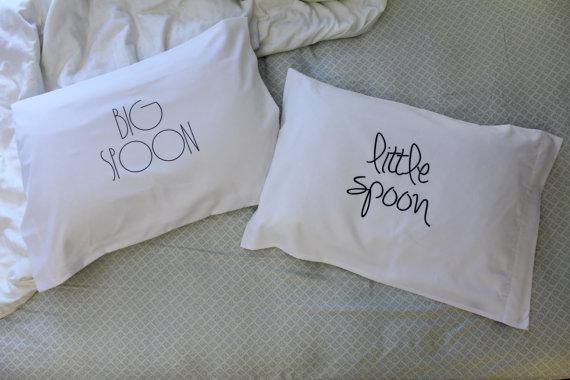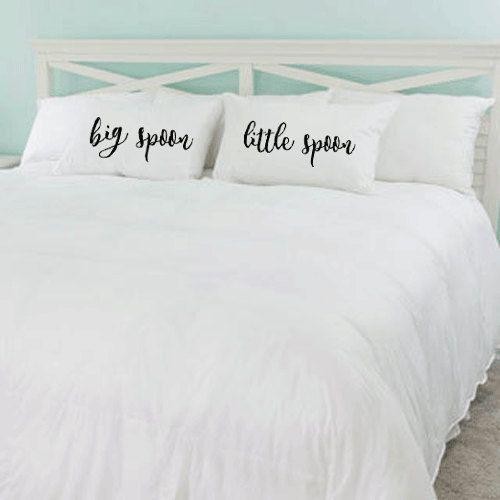The first image is the image on the left, the second image is the image on the right. Evaluate the accuracy of this statement regarding the images: "There are more pillows in the image on the left than in the image on the right.". Is it true? Answer yes or no. No. The first image is the image on the left, the second image is the image on the right. Evaluate the accuracy of this statement regarding the images: "A set of pillows features same-style bold all lower-case cursive lettering, while the other set features at least one pillow with non-cursive writing.". Is it true? Answer yes or no. Yes. 